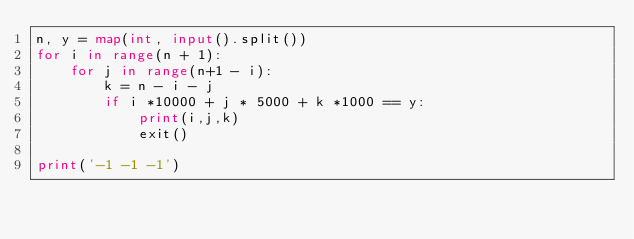Convert code to text. <code><loc_0><loc_0><loc_500><loc_500><_Python_>n, y = map(int, input().split())
for i in range(n + 1):
	for j in range(n+1 - i):
		k = n - i - j
		if i *10000 + j * 5000 + k *1000 == y:
			print(i,j,k)
			exit()
			
print('-1 -1 -1')</code> 